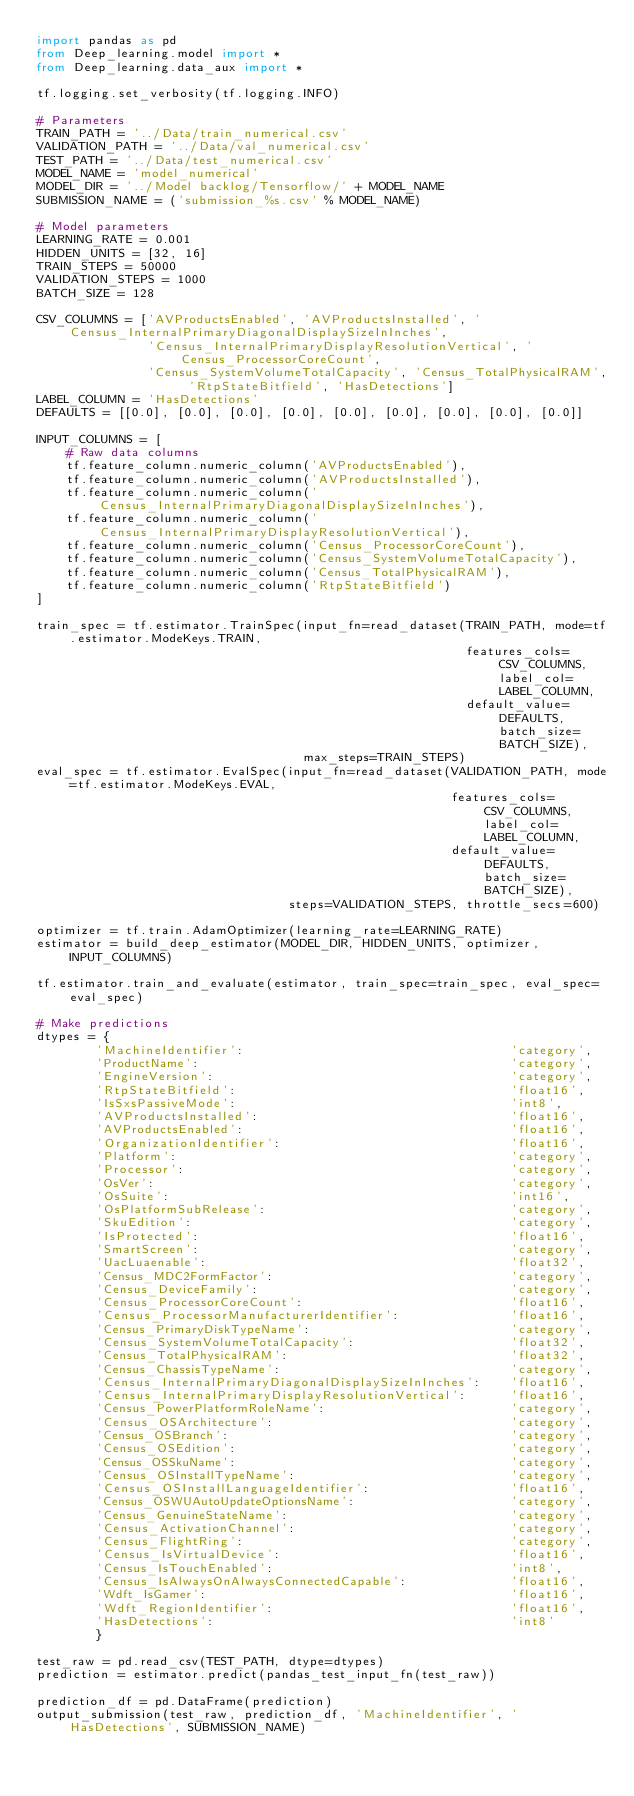Convert code to text. <code><loc_0><loc_0><loc_500><loc_500><_Python_>import pandas as pd
from Deep_learning.model import *
from Deep_learning.data_aux import *

tf.logging.set_verbosity(tf.logging.INFO)

# Parameters
TRAIN_PATH = '../Data/train_numerical.csv'
VALIDATION_PATH = '../Data/val_numerical.csv'
TEST_PATH = '../Data/test_numerical.csv'
MODEL_NAME = 'model_numerical'
MODEL_DIR = '../Model backlog/Tensorflow/' + MODEL_NAME
SUBMISSION_NAME = ('submission_%s.csv' % MODEL_NAME)

# Model parameters
LEARNING_RATE = 0.001
HIDDEN_UNITS = [32, 16]
TRAIN_STEPS = 50000
VALIDATION_STEPS = 1000
BATCH_SIZE = 128

CSV_COLUMNS = ['AVProductsEnabled', 'AVProductsInstalled', 'Census_InternalPrimaryDiagonalDisplaySizeInInches',
               'Census_InternalPrimaryDisplayResolutionVertical', 'Census_ProcessorCoreCount',
               'Census_SystemVolumeTotalCapacity', 'Census_TotalPhysicalRAM', 'RtpStateBitfield', 'HasDetections']
LABEL_COLUMN = 'HasDetections'
DEFAULTS = [[0.0], [0.0], [0.0], [0.0], [0.0], [0.0], [0.0], [0.0], [0.0]]

INPUT_COLUMNS = [
    # Raw data columns
    tf.feature_column.numeric_column('AVProductsEnabled'),
    tf.feature_column.numeric_column('AVProductsInstalled'),
    tf.feature_column.numeric_column('Census_InternalPrimaryDiagonalDisplaySizeInInches'),
    tf.feature_column.numeric_column('Census_InternalPrimaryDisplayResolutionVertical'),
    tf.feature_column.numeric_column('Census_ProcessorCoreCount'),
    tf.feature_column.numeric_column('Census_SystemVolumeTotalCapacity'),
    tf.feature_column.numeric_column('Census_TotalPhysicalRAM'),
    tf.feature_column.numeric_column('RtpStateBitfield')
]

train_spec = tf.estimator.TrainSpec(input_fn=read_dataset(TRAIN_PATH, mode=tf.estimator.ModeKeys.TRAIN,
                                                          features_cols=CSV_COLUMNS, label_col=LABEL_COLUMN,
                                                          default_value=DEFAULTS, batch_size=BATCH_SIZE),
                                    max_steps=TRAIN_STEPS)
eval_spec = tf.estimator.EvalSpec(input_fn=read_dataset(VALIDATION_PATH, mode=tf.estimator.ModeKeys.EVAL,
                                                        features_cols=CSV_COLUMNS, label_col=LABEL_COLUMN,
                                                        default_value=DEFAULTS, batch_size=BATCH_SIZE),
                                  steps=VALIDATION_STEPS, throttle_secs=600)

optimizer = tf.train.AdamOptimizer(learning_rate=LEARNING_RATE)
estimator = build_deep_estimator(MODEL_DIR, HIDDEN_UNITS, optimizer, INPUT_COLUMNS)

tf.estimator.train_and_evaluate(estimator, train_spec=train_spec, eval_spec=eval_spec)

# Make predictions
dtypes = {
        'MachineIdentifier':                                    'category',
        'ProductName':                                          'category',
        'EngineVersion':                                        'category',
        'RtpStateBitfield':                                     'float16',
        'IsSxsPassiveMode':                                     'int8',
        'AVProductsInstalled':                                  'float16',
        'AVProductsEnabled':                                    'float16',
        'OrganizationIdentifier':                               'float16',
        'Platform':                                             'category',
        'Processor':                                            'category',
        'OsVer':                                                'category',
        'OsSuite':                                              'int16',
        'OsPlatformSubRelease':                                 'category',
        'SkuEdition':                                           'category',
        'IsProtected':                                          'float16',
        'SmartScreen':                                          'category',
        'UacLuaenable':                                         'float32',
        'Census_MDC2FormFactor':                                'category',
        'Census_DeviceFamily':                                  'category',
        'Census_ProcessorCoreCount':                            'float16',
        'Census_ProcessorManufacturerIdentifier':               'float16',
        'Census_PrimaryDiskTypeName':                           'category',
        'Census_SystemVolumeTotalCapacity':                     'float32',
        'Census_TotalPhysicalRAM':                              'float32',
        'Census_ChassisTypeName':                               'category',
        'Census_InternalPrimaryDiagonalDisplaySizeInInches':    'float16',
        'Census_InternalPrimaryDisplayResolutionVertical':      'float16',
        'Census_PowerPlatformRoleName':                         'category',
        'Census_OSArchitecture':                                'category',
        'Census_OSBranch':                                      'category',
        'Census_OSEdition':                                     'category',
        'Census_OSSkuName':                                     'category',
        'Census_OSInstallTypeName':                             'category',
        'Census_OSInstallLanguageIdentifier':                   'float16',
        'Census_OSWUAutoUpdateOptionsName':                     'category',
        'Census_GenuineStateName':                              'category',
        'Census_ActivationChannel':                             'category',
        'Census_FlightRing':                                    'category',
        'Census_IsVirtualDevice':                               'float16',
        'Census_IsTouchEnabled':                                'int8',
        'Census_IsAlwaysOnAlwaysConnectedCapable':              'float16',
        'Wdft_IsGamer':                                         'float16',
        'Wdft_RegionIdentifier':                                'float16',
        'HasDetections':                                        'int8'
        }

test_raw = pd.read_csv(TEST_PATH, dtype=dtypes)
prediction = estimator.predict(pandas_test_input_fn(test_raw))

prediction_df = pd.DataFrame(prediction)
output_submission(test_raw, prediction_df, 'MachineIdentifier', 'HasDetections', SUBMISSION_NAME)
</code> 